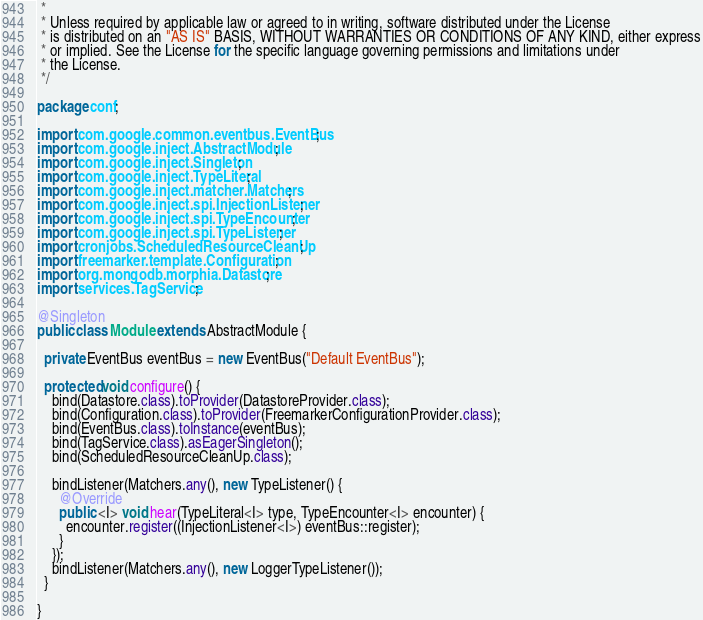<code> <loc_0><loc_0><loc_500><loc_500><_Java_> *
 * Unless required by applicable law or agreed to in writing, software distributed under the License
 * is distributed on an "AS IS" BASIS, WITHOUT WARRANTIES OR CONDITIONS OF ANY KIND, either express
 * or implied. See the License for the specific language governing permissions and limitations under
 * the License.
 */

package conf;

import com.google.common.eventbus.EventBus;
import com.google.inject.AbstractModule;
import com.google.inject.Singleton;
import com.google.inject.TypeLiteral;
import com.google.inject.matcher.Matchers;
import com.google.inject.spi.InjectionListener;
import com.google.inject.spi.TypeEncounter;
import com.google.inject.spi.TypeListener;
import cronjobs.ScheduledResourceCleanUp;
import freemarker.template.Configuration;
import org.mongodb.morphia.Datastore;
import services.TagService;

@Singleton
public class Module extends AbstractModule {

  private EventBus eventBus = new EventBus("Default EventBus");

  protected void configure() {
    bind(Datastore.class).toProvider(DatastoreProvider.class);
    bind(Configuration.class).toProvider(FreemarkerConfigurationProvider.class);
    bind(EventBus.class).toInstance(eventBus);
    bind(TagService.class).asEagerSingleton();
    bind(ScheduledResourceCleanUp.class);

    bindListener(Matchers.any(), new TypeListener() {
      @Override
      public <I> void hear(TypeLiteral<I> type, TypeEncounter<I> encounter) {
        encounter.register((InjectionListener<I>) eventBus::register);
      }
    });
    bindListener(Matchers.any(), new LoggerTypeListener());
  }

}
</code> 